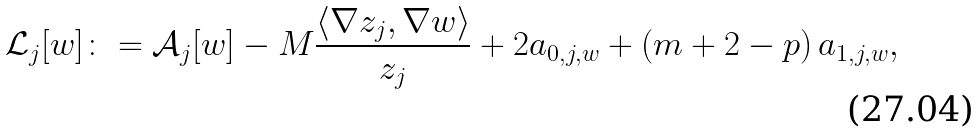<formula> <loc_0><loc_0><loc_500><loc_500>\mathcal { L } _ { j } [ w ] \colon = \mathcal { A } _ { j } [ w ] - M \frac { \langle \nabla z _ { j } , \nabla w \rangle } { z _ { j } } + 2 a _ { 0 , j , w } + \left ( m + 2 - p \right ) a _ { 1 , j , w } ,</formula> 